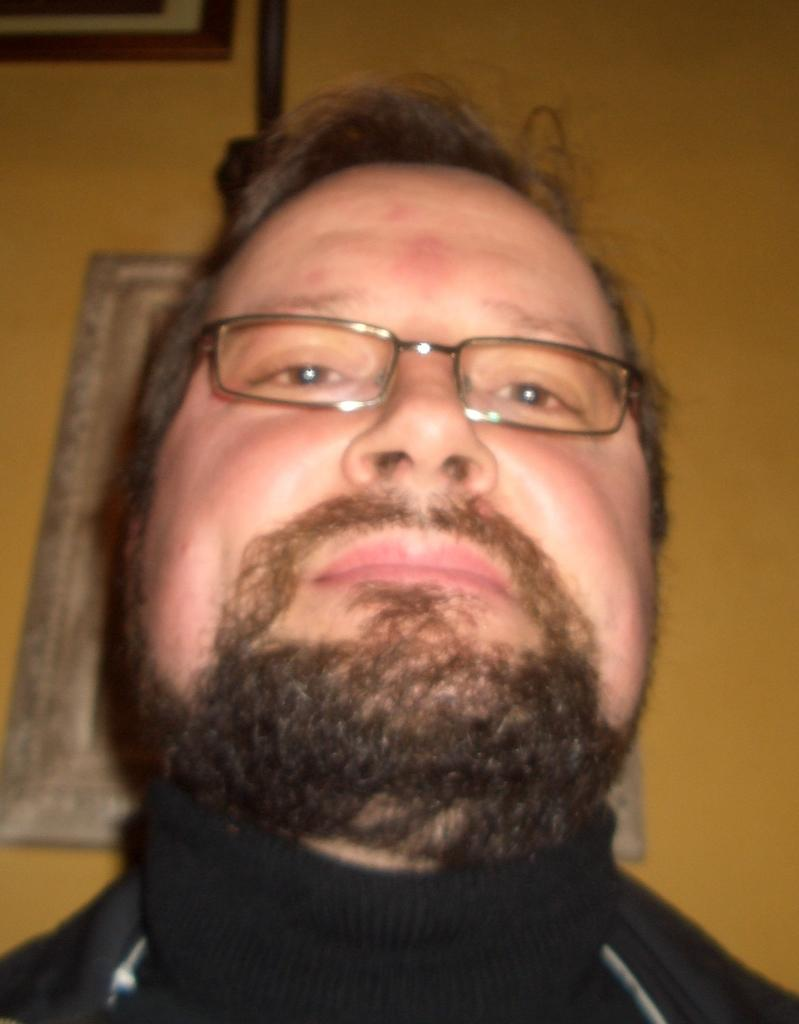Who is present in the image? There is a man in the image. Can you describe the man's appearance? The man has a beard and is wearing glasses. What color is the wall in the background of the image? There is a yellow wall in the background of the image. What can be seen on the yellow wall? There is a photo frame on the yellow wall. What type of paint is the man using in the image? There is no paint or painting activity present in the image. 